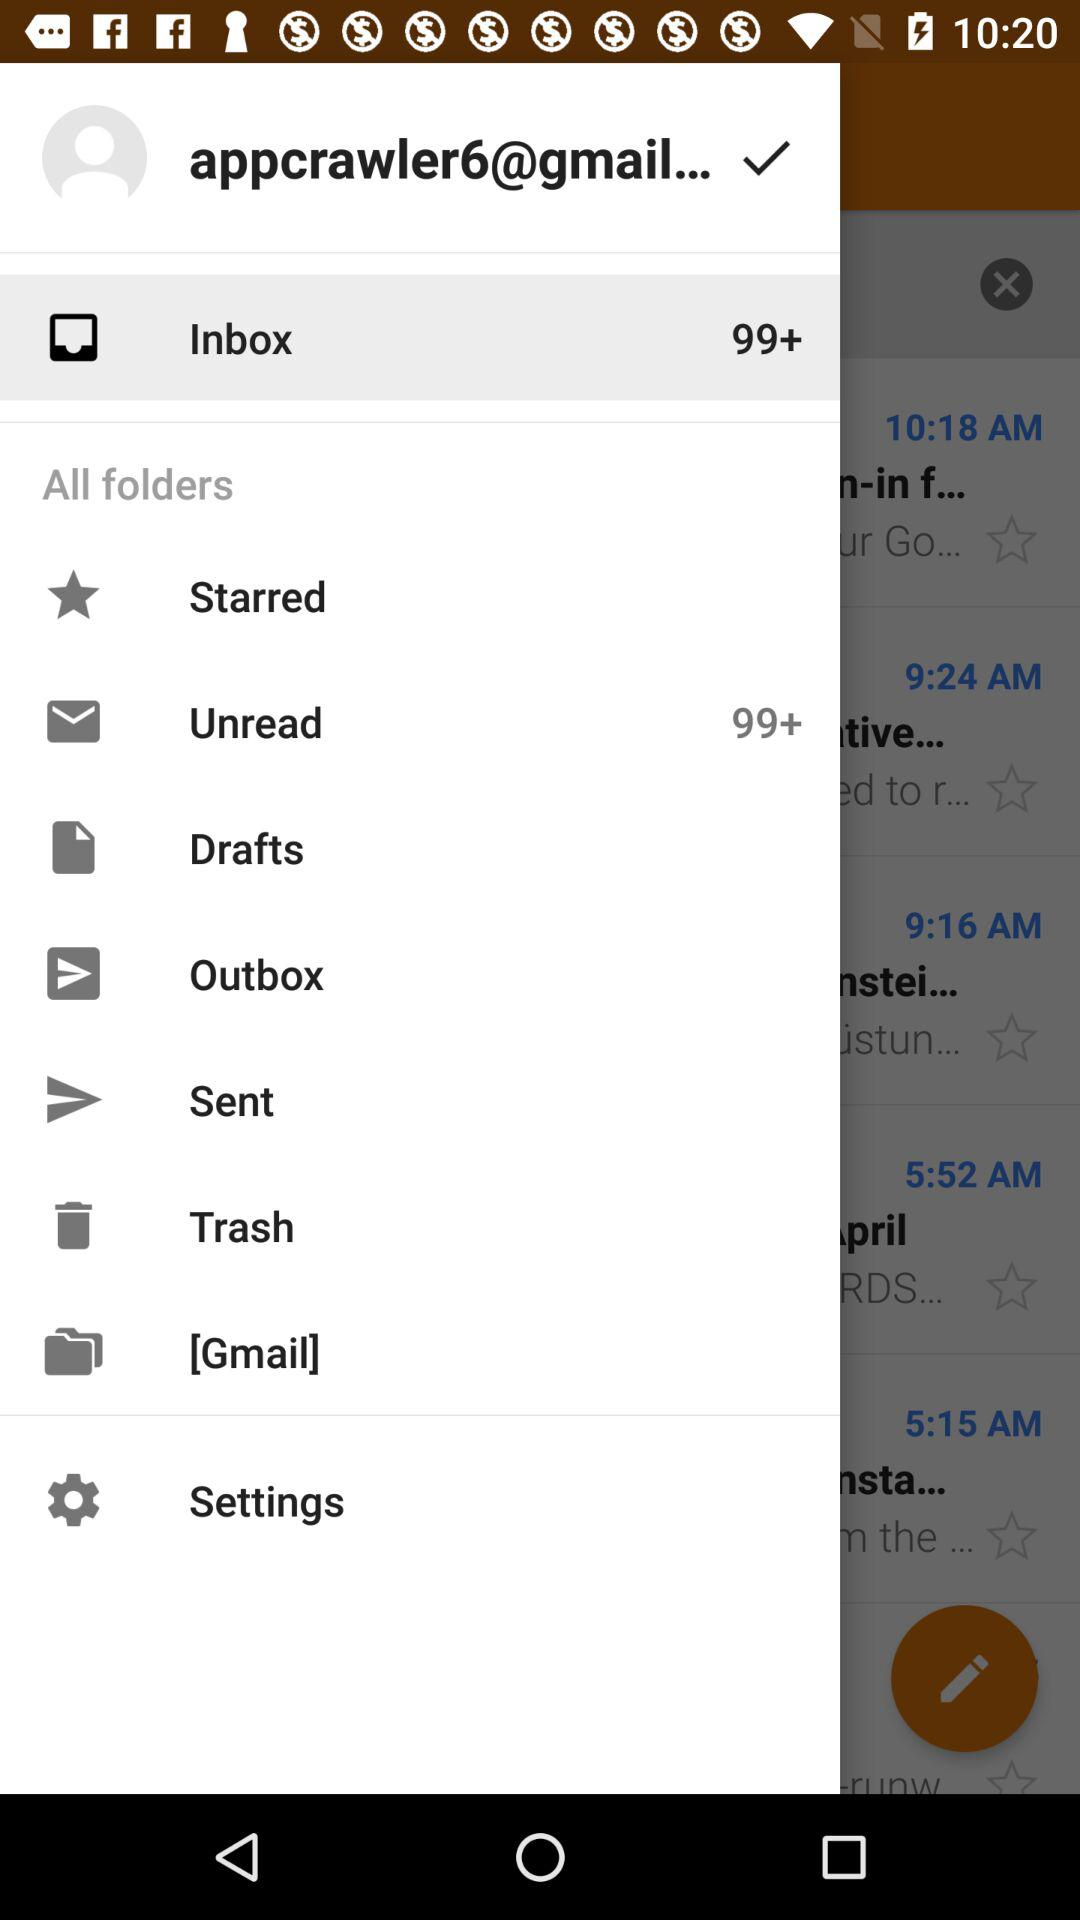How many unread emails are there? There are 99+ unread emails. 